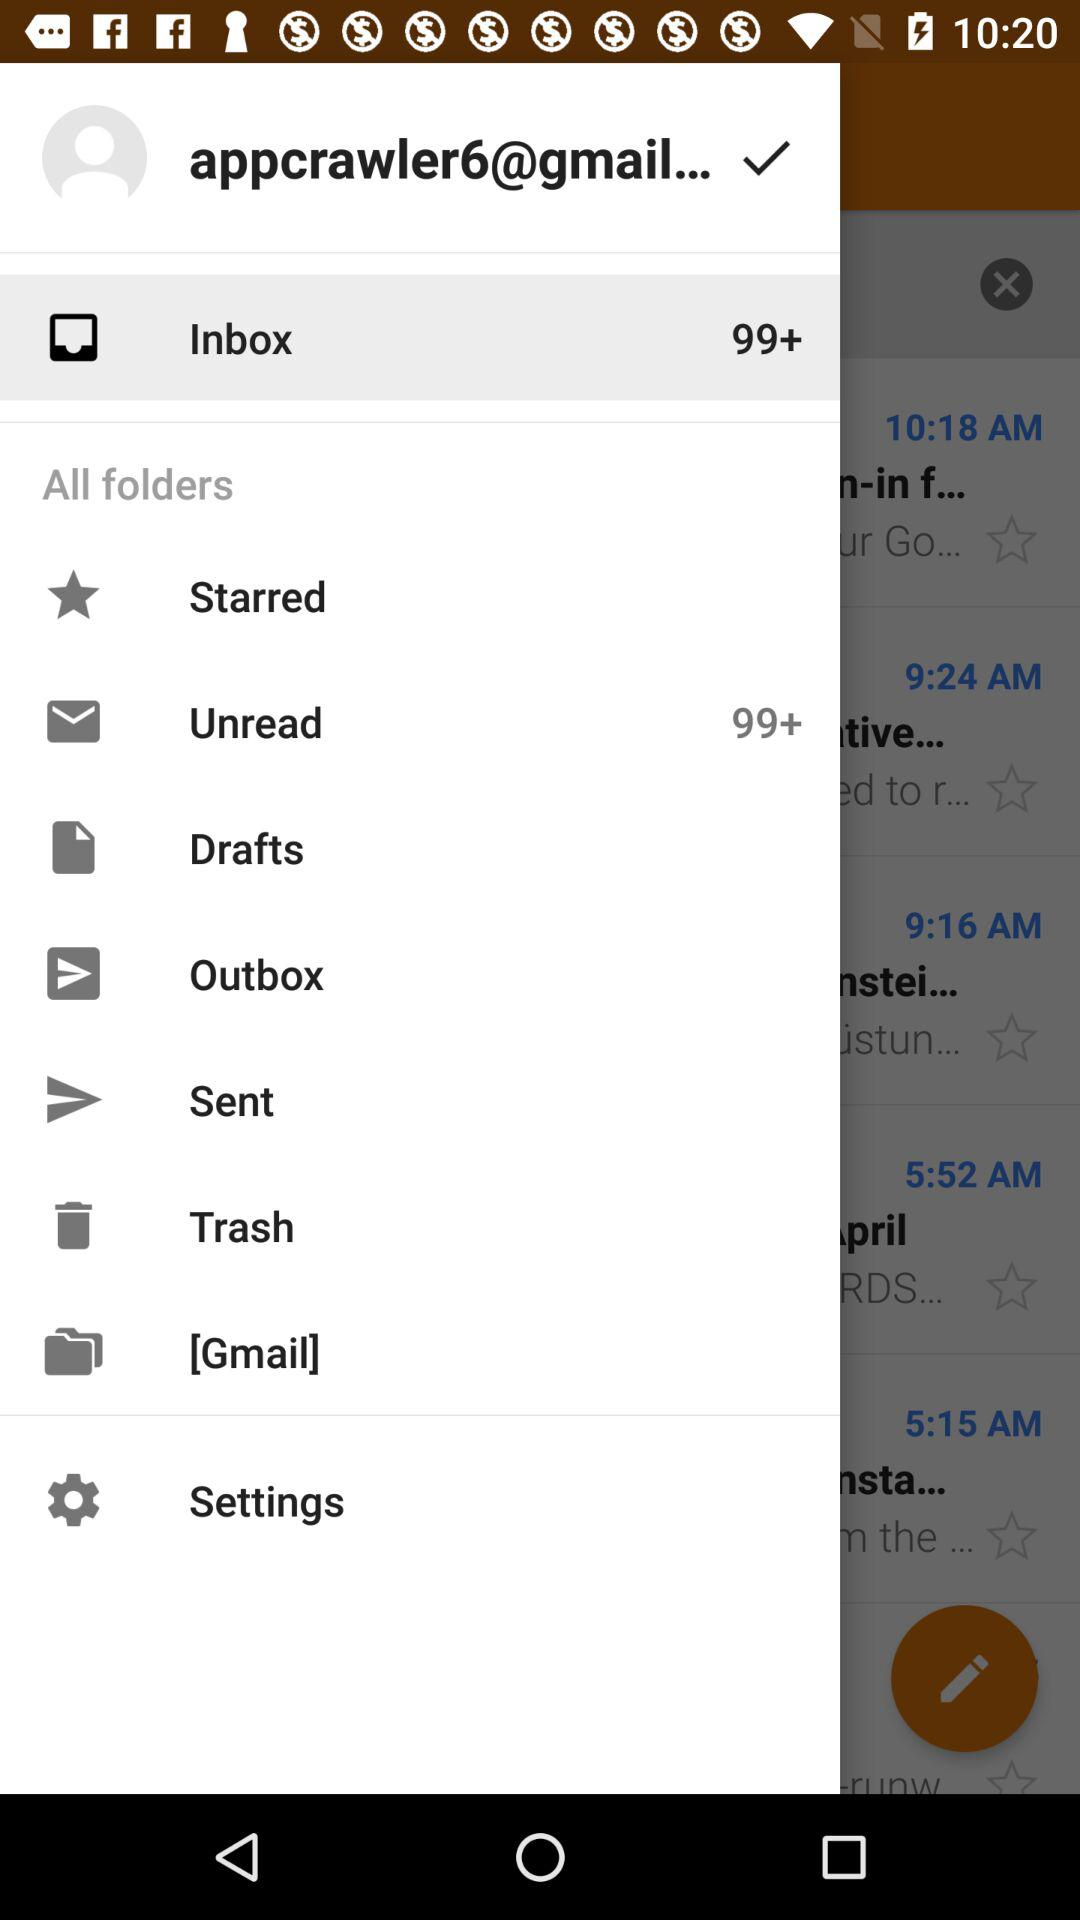How many unread emails are there? There are 99+ unread emails. 